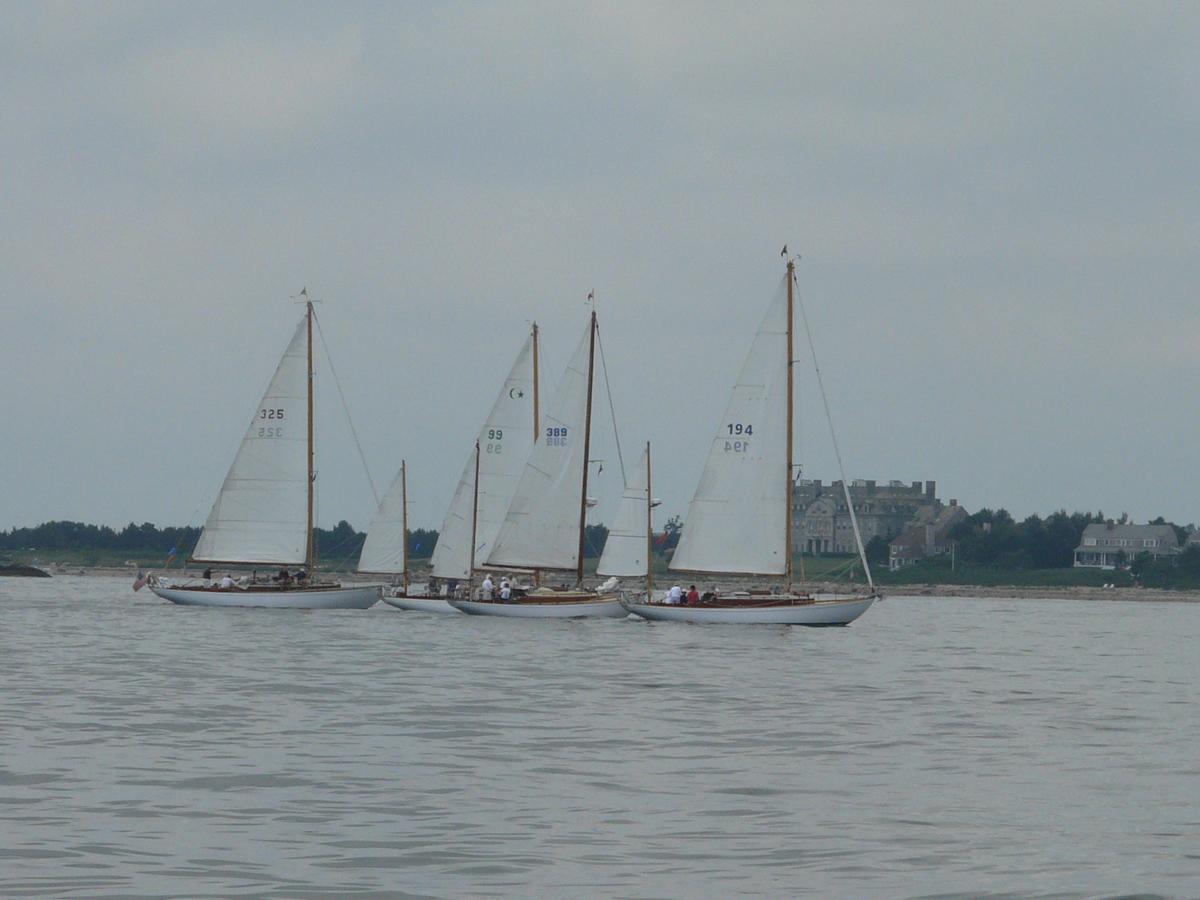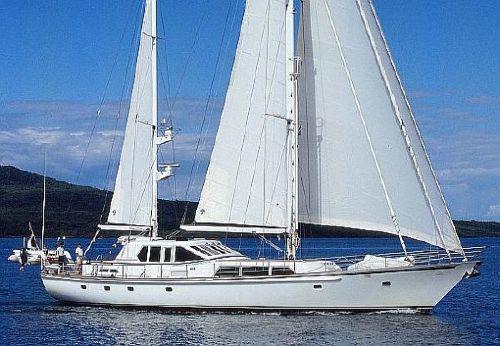The first image is the image on the left, the second image is the image on the right. Evaluate the accuracy of this statement regarding the images: "There is just one sailboat in one of the images, but the other has at least three sailboats.". Is it true? Answer yes or no. Yes. The first image is the image on the left, the second image is the image on the right. Given the left and right images, does the statement "In at least one image there is a white boat facing right sailing on the water." hold true? Answer yes or no. Yes. 